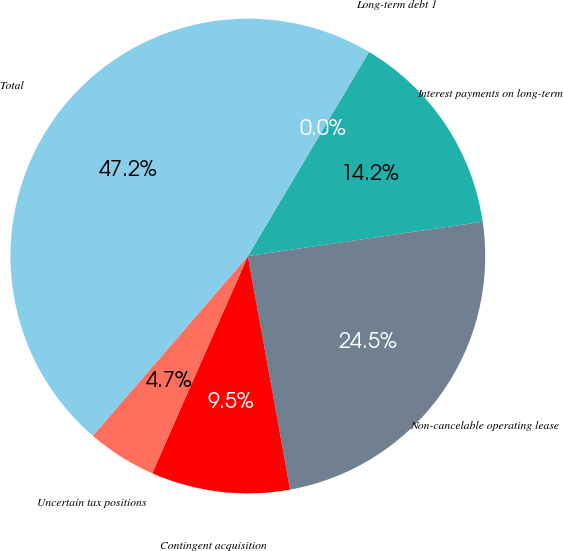Convert chart. <chart><loc_0><loc_0><loc_500><loc_500><pie_chart><fcel>Long-term debt 1<fcel>Interest payments on long-term<fcel>Non-cancelable operating lease<fcel>Contingent acquisition<fcel>Uncertain tax positions<fcel>Total<nl><fcel>0.01%<fcel>14.16%<fcel>24.46%<fcel>9.45%<fcel>4.73%<fcel>47.18%<nl></chart> 